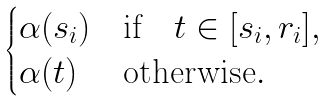Convert formula to latex. <formula><loc_0><loc_0><loc_500><loc_500>\begin{cases} \alpha ( s _ { i } ) & \text {if} \quad t \in [ s _ { i } , r _ { i } ] , \\ \alpha ( t ) & \text {otherwise} . \end{cases}</formula> 